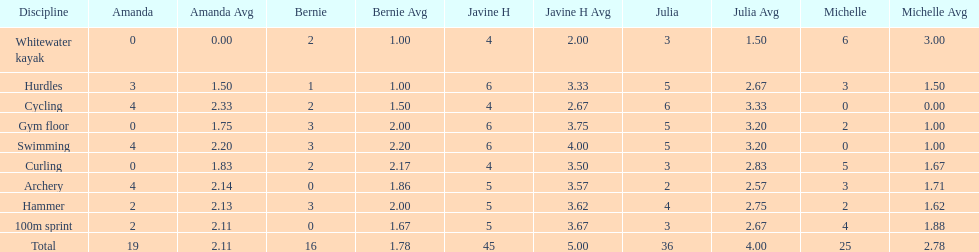Who is the swifter runner? Javine H. 